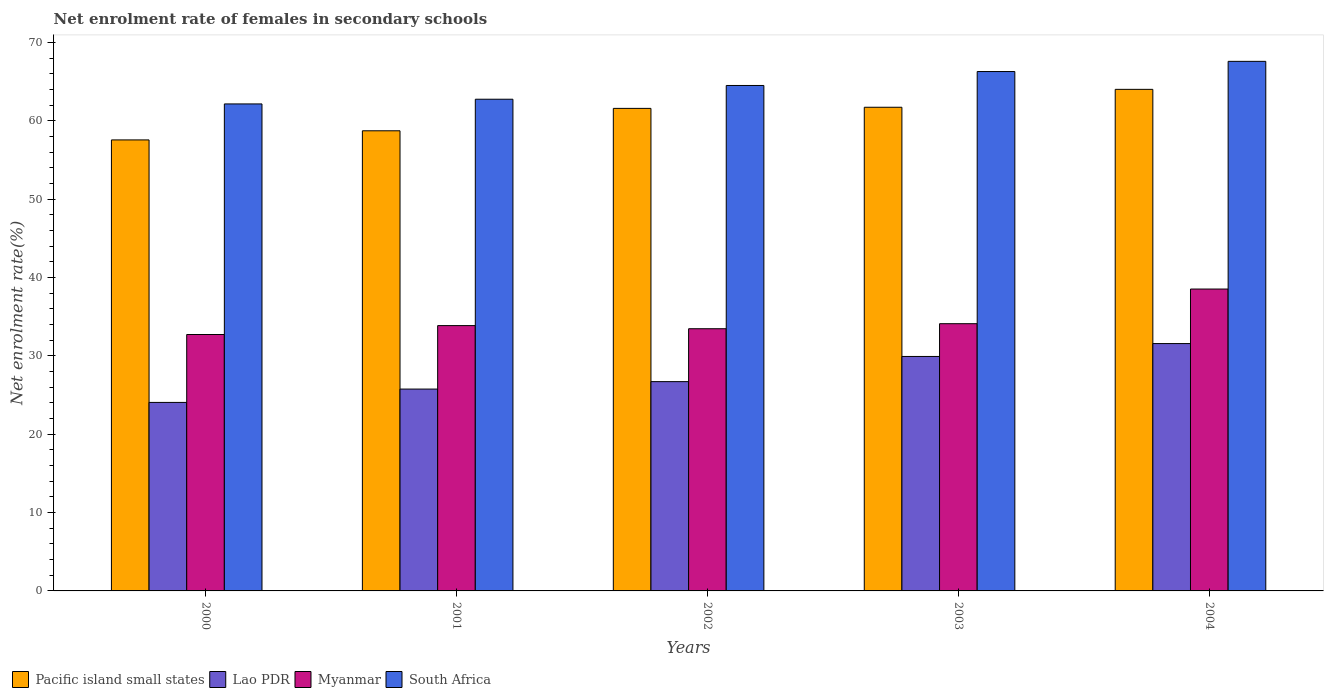How many bars are there on the 3rd tick from the left?
Give a very brief answer. 4. What is the net enrolment rate of females in secondary schools in Myanmar in 2000?
Offer a terse response. 32.73. Across all years, what is the maximum net enrolment rate of females in secondary schools in Myanmar?
Your answer should be very brief. 38.54. Across all years, what is the minimum net enrolment rate of females in secondary schools in Myanmar?
Make the answer very short. 32.73. What is the total net enrolment rate of females in secondary schools in Myanmar in the graph?
Your answer should be very brief. 172.73. What is the difference between the net enrolment rate of females in secondary schools in South Africa in 2002 and that in 2004?
Offer a very short reply. -3.08. What is the difference between the net enrolment rate of females in secondary schools in South Africa in 2001 and the net enrolment rate of females in secondary schools in Myanmar in 2004?
Make the answer very short. 24.23. What is the average net enrolment rate of females in secondary schools in South Africa per year?
Your response must be concise. 64.67. In the year 2000, what is the difference between the net enrolment rate of females in secondary schools in Lao PDR and net enrolment rate of females in secondary schools in Pacific island small states?
Offer a terse response. -33.51. What is the ratio of the net enrolment rate of females in secondary schools in South Africa in 2000 to that in 2002?
Keep it short and to the point. 0.96. Is the net enrolment rate of females in secondary schools in South Africa in 2000 less than that in 2001?
Keep it short and to the point. Yes. What is the difference between the highest and the second highest net enrolment rate of females in secondary schools in Myanmar?
Provide a short and direct response. 4.42. What is the difference between the highest and the lowest net enrolment rate of females in secondary schools in South Africa?
Provide a short and direct response. 5.44. Is the sum of the net enrolment rate of females in secondary schools in South Africa in 2001 and 2004 greater than the maximum net enrolment rate of females in secondary schools in Myanmar across all years?
Provide a short and direct response. Yes. What does the 4th bar from the left in 2004 represents?
Offer a very short reply. South Africa. What does the 2nd bar from the right in 2001 represents?
Make the answer very short. Myanmar. Is it the case that in every year, the sum of the net enrolment rate of females in secondary schools in Myanmar and net enrolment rate of females in secondary schools in South Africa is greater than the net enrolment rate of females in secondary schools in Pacific island small states?
Give a very brief answer. Yes. How many bars are there?
Ensure brevity in your answer.  20. Are the values on the major ticks of Y-axis written in scientific E-notation?
Provide a succinct answer. No. Does the graph contain any zero values?
Provide a succinct answer. No. Does the graph contain grids?
Your answer should be compact. No. How many legend labels are there?
Give a very brief answer. 4. What is the title of the graph?
Your response must be concise. Net enrolment rate of females in secondary schools. What is the label or title of the X-axis?
Give a very brief answer. Years. What is the label or title of the Y-axis?
Your answer should be very brief. Net enrolment rate(%). What is the Net enrolment rate(%) in Pacific island small states in 2000?
Keep it short and to the point. 57.57. What is the Net enrolment rate(%) in Lao PDR in 2000?
Offer a terse response. 24.06. What is the Net enrolment rate(%) in Myanmar in 2000?
Your answer should be very brief. 32.73. What is the Net enrolment rate(%) of South Africa in 2000?
Provide a succinct answer. 62.17. What is the Net enrolment rate(%) in Pacific island small states in 2001?
Provide a short and direct response. 58.74. What is the Net enrolment rate(%) in Lao PDR in 2001?
Keep it short and to the point. 25.77. What is the Net enrolment rate(%) of Myanmar in 2001?
Provide a short and direct response. 33.87. What is the Net enrolment rate(%) in South Africa in 2001?
Ensure brevity in your answer.  62.77. What is the Net enrolment rate(%) in Pacific island small states in 2002?
Your answer should be very brief. 61.6. What is the Net enrolment rate(%) of Lao PDR in 2002?
Give a very brief answer. 26.72. What is the Net enrolment rate(%) in Myanmar in 2002?
Offer a terse response. 33.47. What is the Net enrolment rate(%) of South Africa in 2002?
Provide a succinct answer. 64.52. What is the Net enrolment rate(%) of Pacific island small states in 2003?
Offer a very short reply. 61.75. What is the Net enrolment rate(%) of Lao PDR in 2003?
Offer a terse response. 29.93. What is the Net enrolment rate(%) of Myanmar in 2003?
Provide a succinct answer. 34.11. What is the Net enrolment rate(%) of South Africa in 2003?
Offer a terse response. 66.3. What is the Net enrolment rate(%) in Pacific island small states in 2004?
Ensure brevity in your answer.  64.03. What is the Net enrolment rate(%) in Lao PDR in 2004?
Keep it short and to the point. 31.58. What is the Net enrolment rate(%) of Myanmar in 2004?
Your answer should be compact. 38.54. What is the Net enrolment rate(%) of South Africa in 2004?
Your answer should be compact. 67.6. Across all years, what is the maximum Net enrolment rate(%) in Pacific island small states?
Make the answer very short. 64.03. Across all years, what is the maximum Net enrolment rate(%) in Lao PDR?
Provide a succinct answer. 31.58. Across all years, what is the maximum Net enrolment rate(%) in Myanmar?
Offer a very short reply. 38.54. Across all years, what is the maximum Net enrolment rate(%) in South Africa?
Provide a succinct answer. 67.6. Across all years, what is the minimum Net enrolment rate(%) of Pacific island small states?
Your answer should be very brief. 57.57. Across all years, what is the minimum Net enrolment rate(%) in Lao PDR?
Your answer should be compact. 24.06. Across all years, what is the minimum Net enrolment rate(%) in Myanmar?
Your answer should be compact. 32.73. Across all years, what is the minimum Net enrolment rate(%) in South Africa?
Offer a terse response. 62.17. What is the total Net enrolment rate(%) of Pacific island small states in the graph?
Offer a terse response. 303.69. What is the total Net enrolment rate(%) in Lao PDR in the graph?
Your answer should be very brief. 138.06. What is the total Net enrolment rate(%) in Myanmar in the graph?
Offer a very short reply. 172.73. What is the total Net enrolment rate(%) of South Africa in the graph?
Your answer should be very brief. 323.37. What is the difference between the Net enrolment rate(%) in Pacific island small states in 2000 and that in 2001?
Your response must be concise. -1.17. What is the difference between the Net enrolment rate(%) in Lao PDR in 2000 and that in 2001?
Offer a terse response. -1.7. What is the difference between the Net enrolment rate(%) in Myanmar in 2000 and that in 2001?
Keep it short and to the point. -1.14. What is the difference between the Net enrolment rate(%) in South Africa in 2000 and that in 2001?
Your answer should be very brief. -0.6. What is the difference between the Net enrolment rate(%) of Pacific island small states in 2000 and that in 2002?
Provide a short and direct response. -4.03. What is the difference between the Net enrolment rate(%) in Lao PDR in 2000 and that in 2002?
Your answer should be compact. -2.65. What is the difference between the Net enrolment rate(%) in Myanmar in 2000 and that in 2002?
Offer a very short reply. -0.74. What is the difference between the Net enrolment rate(%) of South Africa in 2000 and that in 2002?
Provide a succinct answer. -2.36. What is the difference between the Net enrolment rate(%) of Pacific island small states in 2000 and that in 2003?
Offer a very short reply. -4.17. What is the difference between the Net enrolment rate(%) of Lao PDR in 2000 and that in 2003?
Ensure brevity in your answer.  -5.87. What is the difference between the Net enrolment rate(%) of Myanmar in 2000 and that in 2003?
Provide a short and direct response. -1.38. What is the difference between the Net enrolment rate(%) of South Africa in 2000 and that in 2003?
Offer a very short reply. -4.14. What is the difference between the Net enrolment rate(%) of Pacific island small states in 2000 and that in 2004?
Make the answer very short. -6.46. What is the difference between the Net enrolment rate(%) in Lao PDR in 2000 and that in 2004?
Provide a succinct answer. -7.51. What is the difference between the Net enrolment rate(%) of Myanmar in 2000 and that in 2004?
Provide a succinct answer. -5.81. What is the difference between the Net enrolment rate(%) of South Africa in 2000 and that in 2004?
Offer a terse response. -5.44. What is the difference between the Net enrolment rate(%) in Pacific island small states in 2001 and that in 2002?
Offer a very short reply. -2.86. What is the difference between the Net enrolment rate(%) in Lao PDR in 2001 and that in 2002?
Provide a succinct answer. -0.95. What is the difference between the Net enrolment rate(%) in Myanmar in 2001 and that in 2002?
Ensure brevity in your answer.  0.4. What is the difference between the Net enrolment rate(%) in South Africa in 2001 and that in 2002?
Ensure brevity in your answer.  -1.76. What is the difference between the Net enrolment rate(%) of Pacific island small states in 2001 and that in 2003?
Offer a terse response. -3. What is the difference between the Net enrolment rate(%) in Lao PDR in 2001 and that in 2003?
Your answer should be compact. -4.16. What is the difference between the Net enrolment rate(%) of Myanmar in 2001 and that in 2003?
Offer a very short reply. -0.24. What is the difference between the Net enrolment rate(%) in South Africa in 2001 and that in 2003?
Ensure brevity in your answer.  -3.54. What is the difference between the Net enrolment rate(%) of Pacific island small states in 2001 and that in 2004?
Keep it short and to the point. -5.29. What is the difference between the Net enrolment rate(%) of Lao PDR in 2001 and that in 2004?
Make the answer very short. -5.81. What is the difference between the Net enrolment rate(%) of Myanmar in 2001 and that in 2004?
Provide a short and direct response. -4.67. What is the difference between the Net enrolment rate(%) in South Africa in 2001 and that in 2004?
Your answer should be compact. -4.84. What is the difference between the Net enrolment rate(%) of Pacific island small states in 2002 and that in 2003?
Ensure brevity in your answer.  -0.14. What is the difference between the Net enrolment rate(%) in Lao PDR in 2002 and that in 2003?
Your answer should be compact. -3.21. What is the difference between the Net enrolment rate(%) in Myanmar in 2002 and that in 2003?
Your response must be concise. -0.64. What is the difference between the Net enrolment rate(%) of South Africa in 2002 and that in 2003?
Provide a succinct answer. -1.78. What is the difference between the Net enrolment rate(%) of Pacific island small states in 2002 and that in 2004?
Your answer should be very brief. -2.43. What is the difference between the Net enrolment rate(%) of Lao PDR in 2002 and that in 2004?
Provide a succinct answer. -4.86. What is the difference between the Net enrolment rate(%) of Myanmar in 2002 and that in 2004?
Keep it short and to the point. -5.07. What is the difference between the Net enrolment rate(%) in South Africa in 2002 and that in 2004?
Your answer should be very brief. -3.08. What is the difference between the Net enrolment rate(%) in Pacific island small states in 2003 and that in 2004?
Provide a succinct answer. -2.28. What is the difference between the Net enrolment rate(%) of Lao PDR in 2003 and that in 2004?
Offer a very short reply. -1.65. What is the difference between the Net enrolment rate(%) of Myanmar in 2003 and that in 2004?
Your answer should be very brief. -4.42. What is the difference between the Net enrolment rate(%) of South Africa in 2003 and that in 2004?
Ensure brevity in your answer.  -1.3. What is the difference between the Net enrolment rate(%) in Pacific island small states in 2000 and the Net enrolment rate(%) in Lao PDR in 2001?
Make the answer very short. 31.81. What is the difference between the Net enrolment rate(%) of Pacific island small states in 2000 and the Net enrolment rate(%) of Myanmar in 2001?
Ensure brevity in your answer.  23.7. What is the difference between the Net enrolment rate(%) in Pacific island small states in 2000 and the Net enrolment rate(%) in South Africa in 2001?
Keep it short and to the point. -5.19. What is the difference between the Net enrolment rate(%) of Lao PDR in 2000 and the Net enrolment rate(%) of Myanmar in 2001?
Keep it short and to the point. -9.81. What is the difference between the Net enrolment rate(%) of Lao PDR in 2000 and the Net enrolment rate(%) of South Africa in 2001?
Offer a very short reply. -38.7. What is the difference between the Net enrolment rate(%) of Myanmar in 2000 and the Net enrolment rate(%) of South Africa in 2001?
Your answer should be compact. -30.04. What is the difference between the Net enrolment rate(%) in Pacific island small states in 2000 and the Net enrolment rate(%) in Lao PDR in 2002?
Make the answer very short. 30.86. What is the difference between the Net enrolment rate(%) in Pacific island small states in 2000 and the Net enrolment rate(%) in Myanmar in 2002?
Ensure brevity in your answer.  24.1. What is the difference between the Net enrolment rate(%) in Pacific island small states in 2000 and the Net enrolment rate(%) in South Africa in 2002?
Give a very brief answer. -6.95. What is the difference between the Net enrolment rate(%) in Lao PDR in 2000 and the Net enrolment rate(%) in Myanmar in 2002?
Give a very brief answer. -9.41. What is the difference between the Net enrolment rate(%) in Lao PDR in 2000 and the Net enrolment rate(%) in South Africa in 2002?
Ensure brevity in your answer.  -40.46. What is the difference between the Net enrolment rate(%) of Myanmar in 2000 and the Net enrolment rate(%) of South Africa in 2002?
Offer a very short reply. -31.79. What is the difference between the Net enrolment rate(%) in Pacific island small states in 2000 and the Net enrolment rate(%) in Lao PDR in 2003?
Provide a short and direct response. 27.64. What is the difference between the Net enrolment rate(%) in Pacific island small states in 2000 and the Net enrolment rate(%) in Myanmar in 2003?
Keep it short and to the point. 23.46. What is the difference between the Net enrolment rate(%) in Pacific island small states in 2000 and the Net enrolment rate(%) in South Africa in 2003?
Ensure brevity in your answer.  -8.73. What is the difference between the Net enrolment rate(%) in Lao PDR in 2000 and the Net enrolment rate(%) in Myanmar in 2003?
Make the answer very short. -10.05. What is the difference between the Net enrolment rate(%) in Lao PDR in 2000 and the Net enrolment rate(%) in South Africa in 2003?
Provide a succinct answer. -42.24. What is the difference between the Net enrolment rate(%) of Myanmar in 2000 and the Net enrolment rate(%) of South Africa in 2003?
Offer a very short reply. -33.57. What is the difference between the Net enrolment rate(%) of Pacific island small states in 2000 and the Net enrolment rate(%) of Lao PDR in 2004?
Provide a short and direct response. 26. What is the difference between the Net enrolment rate(%) of Pacific island small states in 2000 and the Net enrolment rate(%) of Myanmar in 2004?
Keep it short and to the point. 19.04. What is the difference between the Net enrolment rate(%) in Pacific island small states in 2000 and the Net enrolment rate(%) in South Africa in 2004?
Your answer should be very brief. -10.03. What is the difference between the Net enrolment rate(%) of Lao PDR in 2000 and the Net enrolment rate(%) of Myanmar in 2004?
Provide a succinct answer. -14.47. What is the difference between the Net enrolment rate(%) of Lao PDR in 2000 and the Net enrolment rate(%) of South Africa in 2004?
Your response must be concise. -43.54. What is the difference between the Net enrolment rate(%) in Myanmar in 2000 and the Net enrolment rate(%) in South Africa in 2004?
Offer a terse response. -34.87. What is the difference between the Net enrolment rate(%) of Pacific island small states in 2001 and the Net enrolment rate(%) of Lao PDR in 2002?
Ensure brevity in your answer.  32.02. What is the difference between the Net enrolment rate(%) of Pacific island small states in 2001 and the Net enrolment rate(%) of Myanmar in 2002?
Your response must be concise. 25.27. What is the difference between the Net enrolment rate(%) in Pacific island small states in 2001 and the Net enrolment rate(%) in South Africa in 2002?
Ensure brevity in your answer.  -5.78. What is the difference between the Net enrolment rate(%) in Lao PDR in 2001 and the Net enrolment rate(%) in Myanmar in 2002?
Ensure brevity in your answer.  -7.7. What is the difference between the Net enrolment rate(%) in Lao PDR in 2001 and the Net enrolment rate(%) in South Africa in 2002?
Provide a succinct answer. -38.76. What is the difference between the Net enrolment rate(%) of Myanmar in 2001 and the Net enrolment rate(%) of South Africa in 2002?
Your answer should be compact. -30.65. What is the difference between the Net enrolment rate(%) of Pacific island small states in 2001 and the Net enrolment rate(%) of Lao PDR in 2003?
Give a very brief answer. 28.81. What is the difference between the Net enrolment rate(%) of Pacific island small states in 2001 and the Net enrolment rate(%) of Myanmar in 2003?
Offer a terse response. 24.63. What is the difference between the Net enrolment rate(%) of Pacific island small states in 2001 and the Net enrolment rate(%) of South Africa in 2003?
Provide a short and direct response. -7.56. What is the difference between the Net enrolment rate(%) of Lao PDR in 2001 and the Net enrolment rate(%) of Myanmar in 2003?
Give a very brief answer. -8.35. What is the difference between the Net enrolment rate(%) of Lao PDR in 2001 and the Net enrolment rate(%) of South Africa in 2003?
Give a very brief answer. -40.54. What is the difference between the Net enrolment rate(%) of Myanmar in 2001 and the Net enrolment rate(%) of South Africa in 2003?
Provide a succinct answer. -32.43. What is the difference between the Net enrolment rate(%) of Pacific island small states in 2001 and the Net enrolment rate(%) of Lao PDR in 2004?
Offer a terse response. 27.16. What is the difference between the Net enrolment rate(%) of Pacific island small states in 2001 and the Net enrolment rate(%) of Myanmar in 2004?
Make the answer very short. 20.2. What is the difference between the Net enrolment rate(%) of Pacific island small states in 2001 and the Net enrolment rate(%) of South Africa in 2004?
Give a very brief answer. -8.86. What is the difference between the Net enrolment rate(%) in Lao PDR in 2001 and the Net enrolment rate(%) in Myanmar in 2004?
Your response must be concise. -12.77. What is the difference between the Net enrolment rate(%) of Lao PDR in 2001 and the Net enrolment rate(%) of South Africa in 2004?
Your response must be concise. -41.84. What is the difference between the Net enrolment rate(%) of Myanmar in 2001 and the Net enrolment rate(%) of South Africa in 2004?
Your answer should be compact. -33.73. What is the difference between the Net enrolment rate(%) in Pacific island small states in 2002 and the Net enrolment rate(%) in Lao PDR in 2003?
Provide a short and direct response. 31.67. What is the difference between the Net enrolment rate(%) in Pacific island small states in 2002 and the Net enrolment rate(%) in Myanmar in 2003?
Offer a terse response. 27.49. What is the difference between the Net enrolment rate(%) in Pacific island small states in 2002 and the Net enrolment rate(%) in South Africa in 2003?
Provide a succinct answer. -4.7. What is the difference between the Net enrolment rate(%) of Lao PDR in 2002 and the Net enrolment rate(%) of Myanmar in 2003?
Make the answer very short. -7.4. What is the difference between the Net enrolment rate(%) of Lao PDR in 2002 and the Net enrolment rate(%) of South Africa in 2003?
Offer a terse response. -39.59. What is the difference between the Net enrolment rate(%) in Myanmar in 2002 and the Net enrolment rate(%) in South Africa in 2003?
Keep it short and to the point. -32.83. What is the difference between the Net enrolment rate(%) in Pacific island small states in 2002 and the Net enrolment rate(%) in Lao PDR in 2004?
Offer a terse response. 30.02. What is the difference between the Net enrolment rate(%) of Pacific island small states in 2002 and the Net enrolment rate(%) of Myanmar in 2004?
Provide a succinct answer. 23.06. What is the difference between the Net enrolment rate(%) of Pacific island small states in 2002 and the Net enrolment rate(%) of South Africa in 2004?
Your answer should be very brief. -6. What is the difference between the Net enrolment rate(%) of Lao PDR in 2002 and the Net enrolment rate(%) of Myanmar in 2004?
Offer a terse response. -11.82. What is the difference between the Net enrolment rate(%) in Lao PDR in 2002 and the Net enrolment rate(%) in South Africa in 2004?
Ensure brevity in your answer.  -40.89. What is the difference between the Net enrolment rate(%) of Myanmar in 2002 and the Net enrolment rate(%) of South Africa in 2004?
Your answer should be compact. -34.13. What is the difference between the Net enrolment rate(%) in Pacific island small states in 2003 and the Net enrolment rate(%) in Lao PDR in 2004?
Keep it short and to the point. 30.17. What is the difference between the Net enrolment rate(%) in Pacific island small states in 2003 and the Net enrolment rate(%) in Myanmar in 2004?
Provide a short and direct response. 23.21. What is the difference between the Net enrolment rate(%) of Pacific island small states in 2003 and the Net enrolment rate(%) of South Africa in 2004?
Provide a short and direct response. -5.86. What is the difference between the Net enrolment rate(%) in Lao PDR in 2003 and the Net enrolment rate(%) in Myanmar in 2004?
Offer a terse response. -8.61. What is the difference between the Net enrolment rate(%) of Lao PDR in 2003 and the Net enrolment rate(%) of South Africa in 2004?
Make the answer very short. -37.67. What is the difference between the Net enrolment rate(%) in Myanmar in 2003 and the Net enrolment rate(%) in South Africa in 2004?
Your answer should be very brief. -33.49. What is the average Net enrolment rate(%) in Pacific island small states per year?
Provide a succinct answer. 60.74. What is the average Net enrolment rate(%) of Lao PDR per year?
Your answer should be compact. 27.61. What is the average Net enrolment rate(%) of Myanmar per year?
Keep it short and to the point. 34.55. What is the average Net enrolment rate(%) in South Africa per year?
Give a very brief answer. 64.67. In the year 2000, what is the difference between the Net enrolment rate(%) of Pacific island small states and Net enrolment rate(%) of Lao PDR?
Offer a terse response. 33.51. In the year 2000, what is the difference between the Net enrolment rate(%) in Pacific island small states and Net enrolment rate(%) in Myanmar?
Offer a terse response. 24.84. In the year 2000, what is the difference between the Net enrolment rate(%) of Pacific island small states and Net enrolment rate(%) of South Africa?
Make the answer very short. -4.59. In the year 2000, what is the difference between the Net enrolment rate(%) of Lao PDR and Net enrolment rate(%) of Myanmar?
Your answer should be very brief. -8.67. In the year 2000, what is the difference between the Net enrolment rate(%) of Lao PDR and Net enrolment rate(%) of South Africa?
Your answer should be very brief. -38.11. In the year 2000, what is the difference between the Net enrolment rate(%) in Myanmar and Net enrolment rate(%) in South Africa?
Provide a succinct answer. -29.44. In the year 2001, what is the difference between the Net enrolment rate(%) in Pacific island small states and Net enrolment rate(%) in Lao PDR?
Offer a terse response. 32.97. In the year 2001, what is the difference between the Net enrolment rate(%) in Pacific island small states and Net enrolment rate(%) in Myanmar?
Offer a very short reply. 24.87. In the year 2001, what is the difference between the Net enrolment rate(%) in Pacific island small states and Net enrolment rate(%) in South Africa?
Ensure brevity in your answer.  -4.03. In the year 2001, what is the difference between the Net enrolment rate(%) of Lao PDR and Net enrolment rate(%) of Myanmar?
Provide a succinct answer. -8.1. In the year 2001, what is the difference between the Net enrolment rate(%) in Lao PDR and Net enrolment rate(%) in South Africa?
Provide a short and direct response. -37. In the year 2001, what is the difference between the Net enrolment rate(%) of Myanmar and Net enrolment rate(%) of South Africa?
Provide a short and direct response. -28.9. In the year 2002, what is the difference between the Net enrolment rate(%) in Pacific island small states and Net enrolment rate(%) in Lao PDR?
Keep it short and to the point. 34.88. In the year 2002, what is the difference between the Net enrolment rate(%) in Pacific island small states and Net enrolment rate(%) in Myanmar?
Your response must be concise. 28.13. In the year 2002, what is the difference between the Net enrolment rate(%) of Pacific island small states and Net enrolment rate(%) of South Africa?
Your answer should be very brief. -2.92. In the year 2002, what is the difference between the Net enrolment rate(%) of Lao PDR and Net enrolment rate(%) of Myanmar?
Make the answer very short. -6.75. In the year 2002, what is the difference between the Net enrolment rate(%) of Lao PDR and Net enrolment rate(%) of South Africa?
Ensure brevity in your answer.  -37.81. In the year 2002, what is the difference between the Net enrolment rate(%) in Myanmar and Net enrolment rate(%) in South Africa?
Provide a short and direct response. -31.05. In the year 2003, what is the difference between the Net enrolment rate(%) of Pacific island small states and Net enrolment rate(%) of Lao PDR?
Your answer should be compact. 31.81. In the year 2003, what is the difference between the Net enrolment rate(%) in Pacific island small states and Net enrolment rate(%) in Myanmar?
Provide a short and direct response. 27.63. In the year 2003, what is the difference between the Net enrolment rate(%) in Pacific island small states and Net enrolment rate(%) in South Africa?
Offer a terse response. -4.56. In the year 2003, what is the difference between the Net enrolment rate(%) of Lao PDR and Net enrolment rate(%) of Myanmar?
Ensure brevity in your answer.  -4.18. In the year 2003, what is the difference between the Net enrolment rate(%) in Lao PDR and Net enrolment rate(%) in South Africa?
Keep it short and to the point. -36.37. In the year 2003, what is the difference between the Net enrolment rate(%) in Myanmar and Net enrolment rate(%) in South Africa?
Keep it short and to the point. -32.19. In the year 2004, what is the difference between the Net enrolment rate(%) of Pacific island small states and Net enrolment rate(%) of Lao PDR?
Provide a short and direct response. 32.45. In the year 2004, what is the difference between the Net enrolment rate(%) of Pacific island small states and Net enrolment rate(%) of Myanmar?
Ensure brevity in your answer.  25.49. In the year 2004, what is the difference between the Net enrolment rate(%) in Pacific island small states and Net enrolment rate(%) in South Africa?
Ensure brevity in your answer.  -3.57. In the year 2004, what is the difference between the Net enrolment rate(%) of Lao PDR and Net enrolment rate(%) of Myanmar?
Your answer should be very brief. -6.96. In the year 2004, what is the difference between the Net enrolment rate(%) in Lao PDR and Net enrolment rate(%) in South Africa?
Make the answer very short. -36.03. In the year 2004, what is the difference between the Net enrolment rate(%) in Myanmar and Net enrolment rate(%) in South Africa?
Make the answer very short. -29.07. What is the ratio of the Net enrolment rate(%) of Pacific island small states in 2000 to that in 2001?
Your response must be concise. 0.98. What is the ratio of the Net enrolment rate(%) in Lao PDR in 2000 to that in 2001?
Offer a terse response. 0.93. What is the ratio of the Net enrolment rate(%) in Myanmar in 2000 to that in 2001?
Your response must be concise. 0.97. What is the ratio of the Net enrolment rate(%) in South Africa in 2000 to that in 2001?
Provide a succinct answer. 0.99. What is the ratio of the Net enrolment rate(%) of Pacific island small states in 2000 to that in 2002?
Your response must be concise. 0.93. What is the ratio of the Net enrolment rate(%) in Lao PDR in 2000 to that in 2002?
Offer a terse response. 0.9. What is the ratio of the Net enrolment rate(%) of Myanmar in 2000 to that in 2002?
Keep it short and to the point. 0.98. What is the ratio of the Net enrolment rate(%) of South Africa in 2000 to that in 2002?
Offer a terse response. 0.96. What is the ratio of the Net enrolment rate(%) of Pacific island small states in 2000 to that in 2003?
Provide a short and direct response. 0.93. What is the ratio of the Net enrolment rate(%) of Lao PDR in 2000 to that in 2003?
Your response must be concise. 0.8. What is the ratio of the Net enrolment rate(%) in Myanmar in 2000 to that in 2003?
Provide a short and direct response. 0.96. What is the ratio of the Net enrolment rate(%) of South Africa in 2000 to that in 2003?
Offer a terse response. 0.94. What is the ratio of the Net enrolment rate(%) of Pacific island small states in 2000 to that in 2004?
Make the answer very short. 0.9. What is the ratio of the Net enrolment rate(%) in Lao PDR in 2000 to that in 2004?
Keep it short and to the point. 0.76. What is the ratio of the Net enrolment rate(%) of Myanmar in 2000 to that in 2004?
Offer a terse response. 0.85. What is the ratio of the Net enrolment rate(%) in South Africa in 2000 to that in 2004?
Provide a succinct answer. 0.92. What is the ratio of the Net enrolment rate(%) of Pacific island small states in 2001 to that in 2002?
Your answer should be very brief. 0.95. What is the ratio of the Net enrolment rate(%) in Lao PDR in 2001 to that in 2002?
Offer a very short reply. 0.96. What is the ratio of the Net enrolment rate(%) of Myanmar in 2001 to that in 2002?
Your answer should be very brief. 1.01. What is the ratio of the Net enrolment rate(%) of South Africa in 2001 to that in 2002?
Make the answer very short. 0.97. What is the ratio of the Net enrolment rate(%) in Pacific island small states in 2001 to that in 2003?
Provide a short and direct response. 0.95. What is the ratio of the Net enrolment rate(%) of Lao PDR in 2001 to that in 2003?
Make the answer very short. 0.86. What is the ratio of the Net enrolment rate(%) of Myanmar in 2001 to that in 2003?
Offer a terse response. 0.99. What is the ratio of the Net enrolment rate(%) of South Africa in 2001 to that in 2003?
Offer a very short reply. 0.95. What is the ratio of the Net enrolment rate(%) in Pacific island small states in 2001 to that in 2004?
Offer a terse response. 0.92. What is the ratio of the Net enrolment rate(%) of Lao PDR in 2001 to that in 2004?
Your response must be concise. 0.82. What is the ratio of the Net enrolment rate(%) of Myanmar in 2001 to that in 2004?
Offer a very short reply. 0.88. What is the ratio of the Net enrolment rate(%) of South Africa in 2001 to that in 2004?
Make the answer very short. 0.93. What is the ratio of the Net enrolment rate(%) in Lao PDR in 2002 to that in 2003?
Ensure brevity in your answer.  0.89. What is the ratio of the Net enrolment rate(%) of Myanmar in 2002 to that in 2003?
Ensure brevity in your answer.  0.98. What is the ratio of the Net enrolment rate(%) of South Africa in 2002 to that in 2003?
Offer a very short reply. 0.97. What is the ratio of the Net enrolment rate(%) of Pacific island small states in 2002 to that in 2004?
Provide a short and direct response. 0.96. What is the ratio of the Net enrolment rate(%) of Lao PDR in 2002 to that in 2004?
Your answer should be compact. 0.85. What is the ratio of the Net enrolment rate(%) in Myanmar in 2002 to that in 2004?
Your response must be concise. 0.87. What is the ratio of the Net enrolment rate(%) in South Africa in 2002 to that in 2004?
Provide a succinct answer. 0.95. What is the ratio of the Net enrolment rate(%) of Pacific island small states in 2003 to that in 2004?
Your answer should be compact. 0.96. What is the ratio of the Net enrolment rate(%) of Lao PDR in 2003 to that in 2004?
Your answer should be compact. 0.95. What is the ratio of the Net enrolment rate(%) of Myanmar in 2003 to that in 2004?
Keep it short and to the point. 0.89. What is the ratio of the Net enrolment rate(%) in South Africa in 2003 to that in 2004?
Your answer should be very brief. 0.98. What is the difference between the highest and the second highest Net enrolment rate(%) of Pacific island small states?
Give a very brief answer. 2.28. What is the difference between the highest and the second highest Net enrolment rate(%) in Lao PDR?
Keep it short and to the point. 1.65. What is the difference between the highest and the second highest Net enrolment rate(%) of Myanmar?
Your answer should be compact. 4.42. What is the difference between the highest and the second highest Net enrolment rate(%) of South Africa?
Your response must be concise. 1.3. What is the difference between the highest and the lowest Net enrolment rate(%) of Pacific island small states?
Your answer should be compact. 6.46. What is the difference between the highest and the lowest Net enrolment rate(%) of Lao PDR?
Keep it short and to the point. 7.51. What is the difference between the highest and the lowest Net enrolment rate(%) in Myanmar?
Offer a terse response. 5.81. What is the difference between the highest and the lowest Net enrolment rate(%) in South Africa?
Make the answer very short. 5.44. 